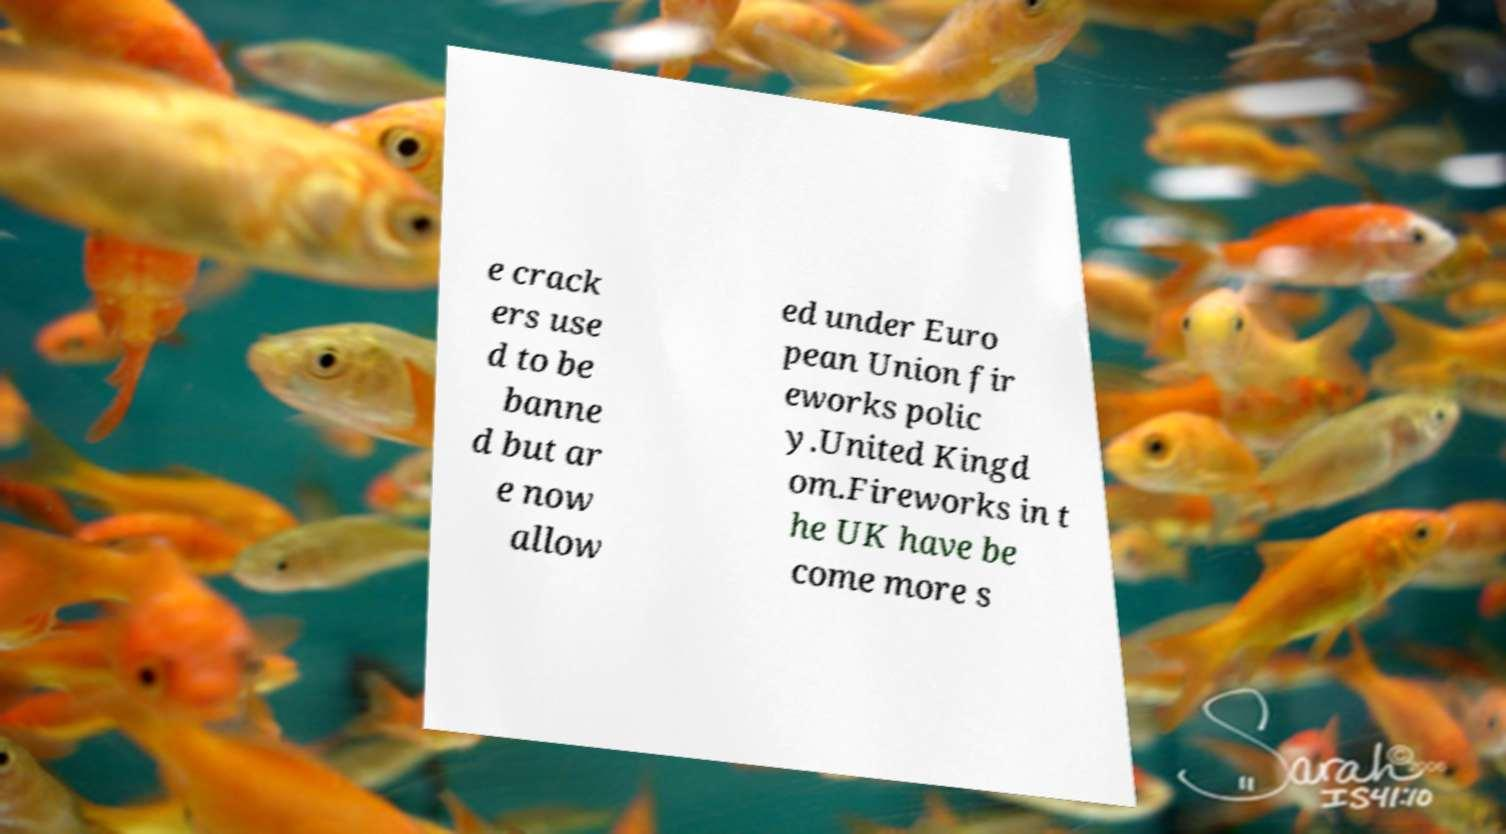Can you read and provide the text displayed in the image?This photo seems to have some interesting text. Can you extract and type it out for me? e crack ers use d to be banne d but ar e now allow ed under Euro pean Union fir eworks polic y.United Kingd om.Fireworks in t he UK have be come more s 